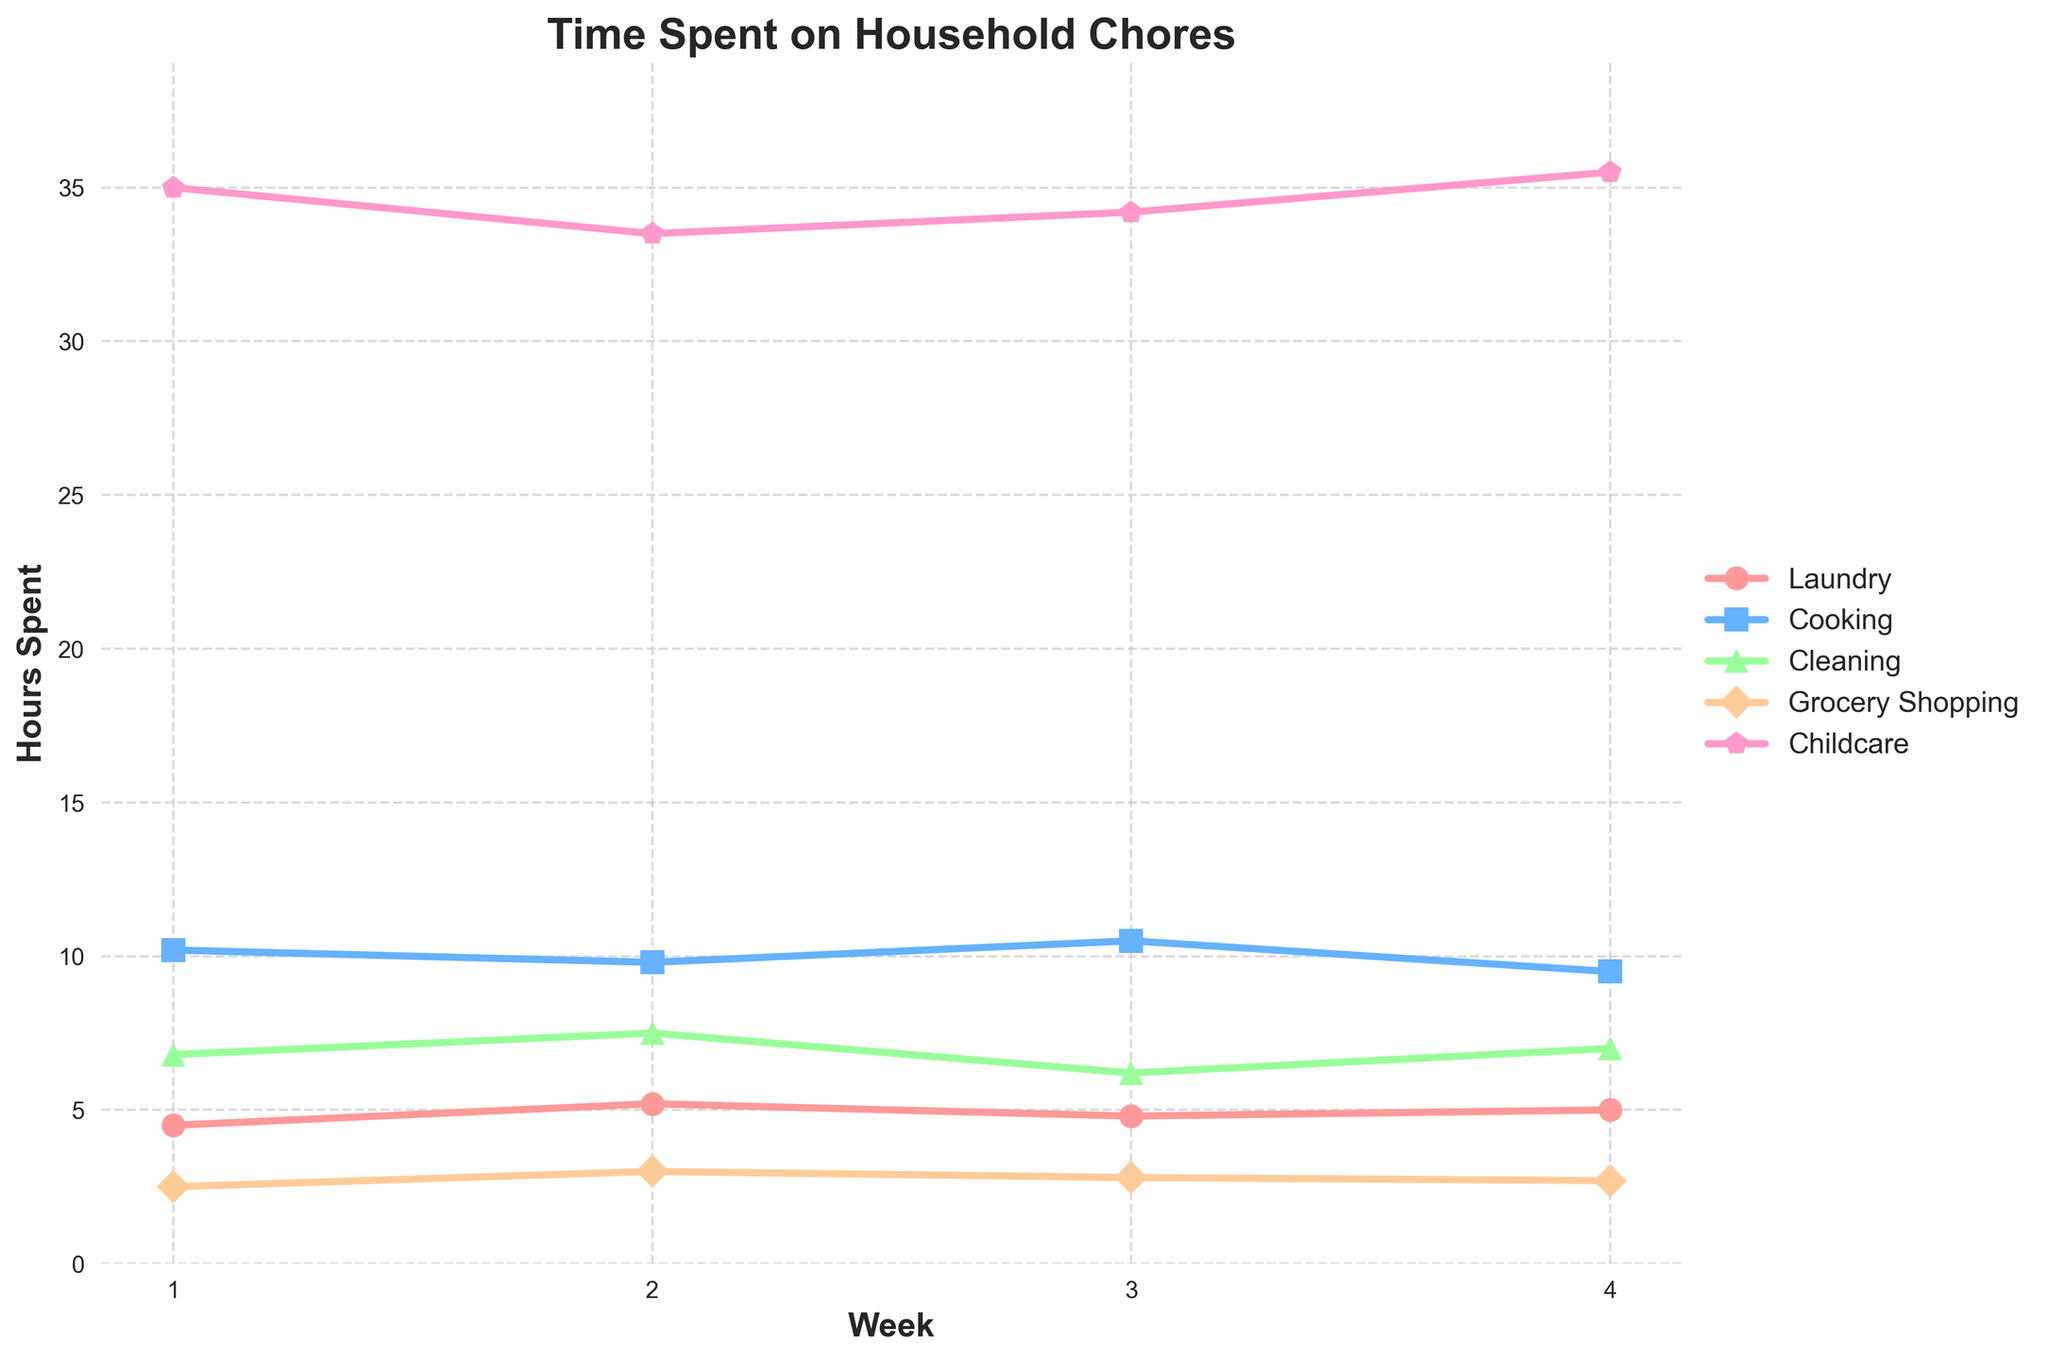What is the total time spent on Laundry in the whole month? Sum up the hours spent on Laundry for each week: 4.5 (week 1) + 5.2 (week 2) + 4.8 (week 3) + 5.0 (week 4) = 19.5 hours
Answer: 19.5 hours Which week had the highest total time spent on household chores? Calculate the sum of all chores for each week: Week 1 (59.0), Week 2 (59.0), Week 3 (58.5), Week 4 (59.7). Week 4 has the highest total time spent.
Answer: Week 4 How does the time spent on Childcare in Week 2 compare with the time spent on Cleaning in the same week? Week 2 time for Childcare is 33.5 hours, and for Cleaning, it is 7.5 hours. 33.5 hours is significantly higher than 7.5 hours.
Answer: Childcare is higher Which chore shows the most fluctuation over the weeks? By visually inspecting the line patterns, the Childcare line shows less fluctuation while others like Cleaning show more changes week by week.
Answer: Cleaning What is the average time spent on Cooking per week? Sum up the time spent on Cooking for each week: 10.2 + 9.8 + 10.5 + 9.5 = 40. Divide by the number of weeks: 40 / 4 = 10.
Answer: 10 hours Between which weeks does the time spent on Grocery Shopping change the most? Calculate the differences between consecutive weeks: Week 1 to Week 2 (0.5), Week 2 to Week 3 (-0.2), Week 3 to Week 4 (-0.1). The greatest change is from Week 1 to Week 2.
Answer: Week 1 to Week 2 What color represents time spent on Cooking? By observing the colors used in the visual representation of data, the color for Cooking appears to be blue.
Answer: Blue Is the average time spent on Laundry higher than the average time spent on Cleaning? Average time for Laundry: (4.5 + 5.2 + 4.8 + 5.0) / 4 = 4.875, for Cleaning: (6.8 + 7.5 + 6.2 + 7.0) / 4 = 6.875. The average for Cleaning is higher.
Answer: No Which chore consistently takes the most time each week? By examining the data and visual representation, Childcare consistently takes the most time each week.
Answer: Childcare How much more time is spent on Childcare than on Laundry in Week 4? Time spent on Childcare in Week 4 is 35.5 hours, and on Laundry is 5.0 hours. The difference: 35.5 - 5.0 = 30.5.
Answer: 30.5 hours 